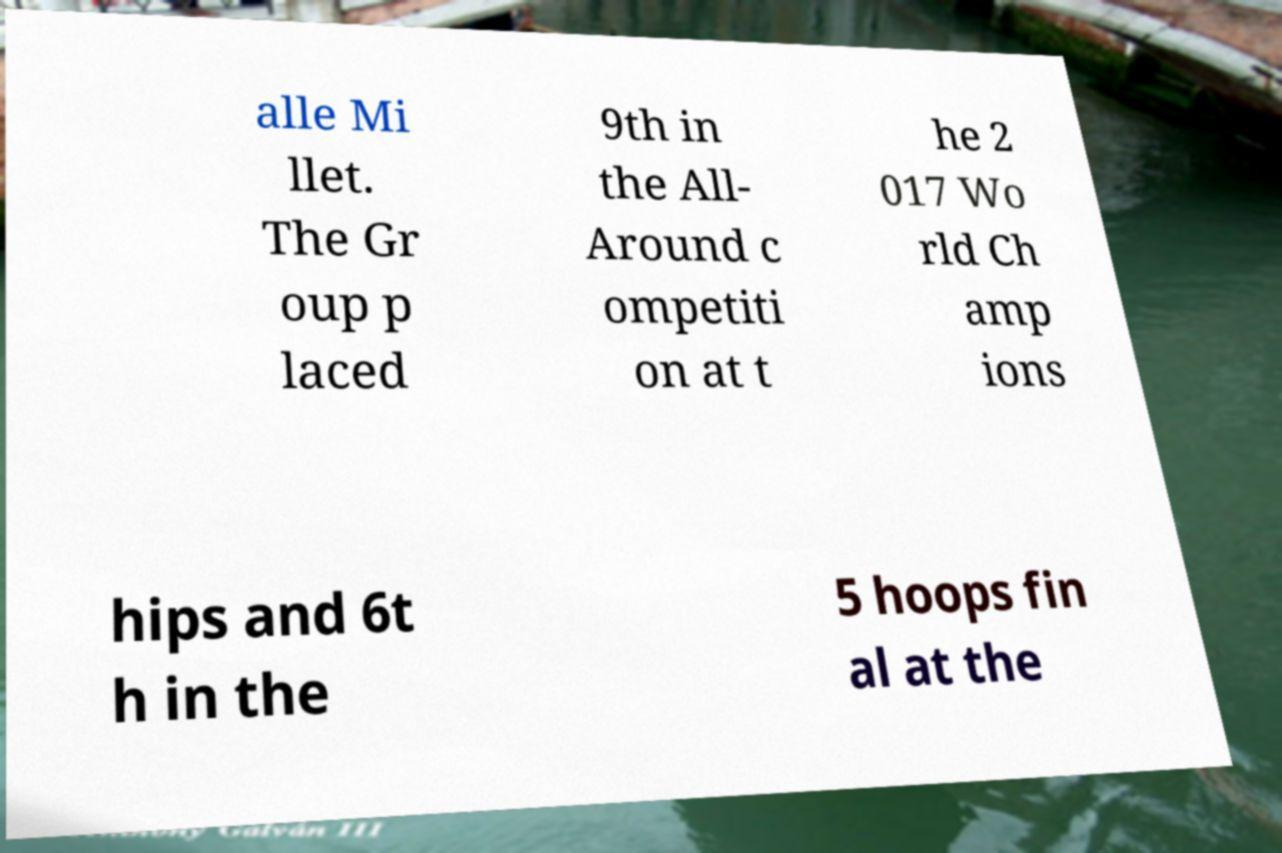Please identify and transcribe the text found in this image. alle Mi llet. The Gr oup p laced 9th in the All- Around c ompetiti on at t he 2 017 Wo rld Ch amp ions hips and 6t h in the 5 hoops fin al at the 